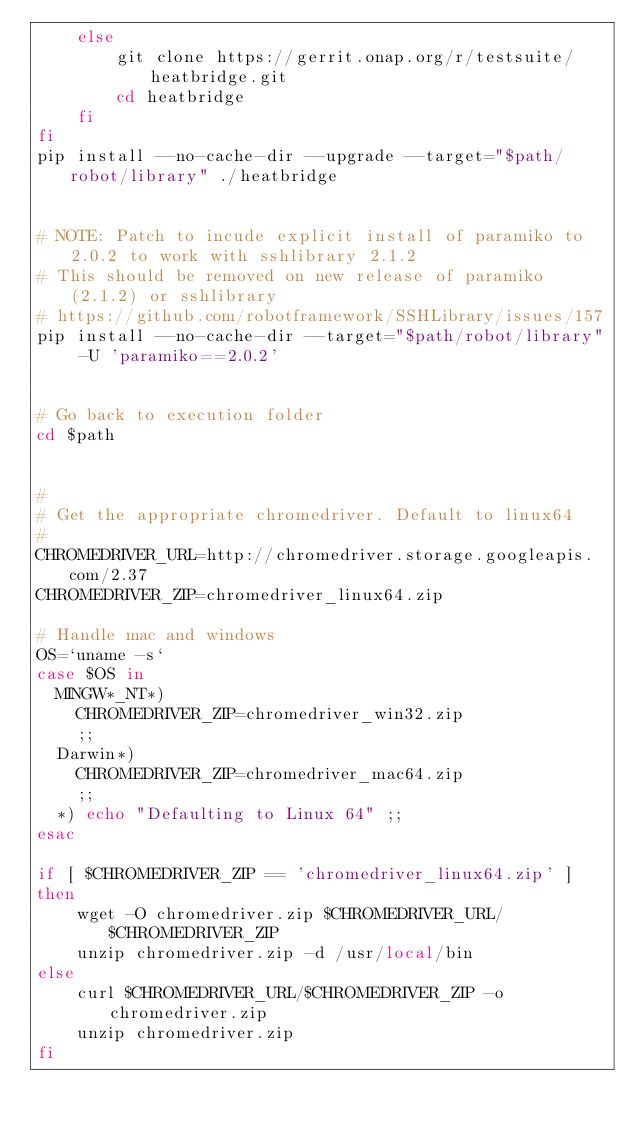Convert code to text. <code><loc_0><loc_0><loc_500><loc_500><_Bash_>	else
		git clone https://gerrit.onap.org/r/testsuite/heatbridge.git
		cd heatbridge
	fi
fi
pip install --no-cache-dir --upgrade --target="$path/robot/library" ./heatbridge


# NOTE: Patch to incude explicit install of paramiko to 2.0.2 to work with sshlibrary 2.1.2
# This should be removed on new release of paramiko (2.1.2) or sshlibrary
# https://github.com/robotframework/SSHLibrary/issues/157
pip install --no-cache-dir --target="$path/robot/library" -U 'paramiko==2.0.2'


# Go back to execution folder
cd $path


#
# Get the appropriate chromedriver. Default to linux64
#
CHROMEDRIVER_URL=http://chromedriver.storage.googleapis.com/2.37
CHROMEDRIVER_ZIP=chromedriver_linux64.zip

# Handle mac and windows
OS=`uname -s`
case $OS in
  MINGW*_NT*)
  	CHROMEDRIVER_ZIP=chromedriver_win32.zip
  	;;
  Darwin*)
  	CHROMEDRIVER_ZIP=chromedriver_mac64.zip
  	;;
  *) echo "Defaulting to Linux 64" ;;
esac

if [ $CHROMEDRIVER_ZIP == 'chromedriver_linux64.zip' ]
then
    wget -O chromedriver.zip $CHROMEDRIVER_URL/$CHROMEDRIVER_ZIP
	unzip chromedriver.zip -d /usr/local/bin
else
    curl $CHROMEDRIVER_URL/$CHROMEDRIVER_ZIP -o chromedriver.zip
	unzip chromedriver.zip
fi
</code> 